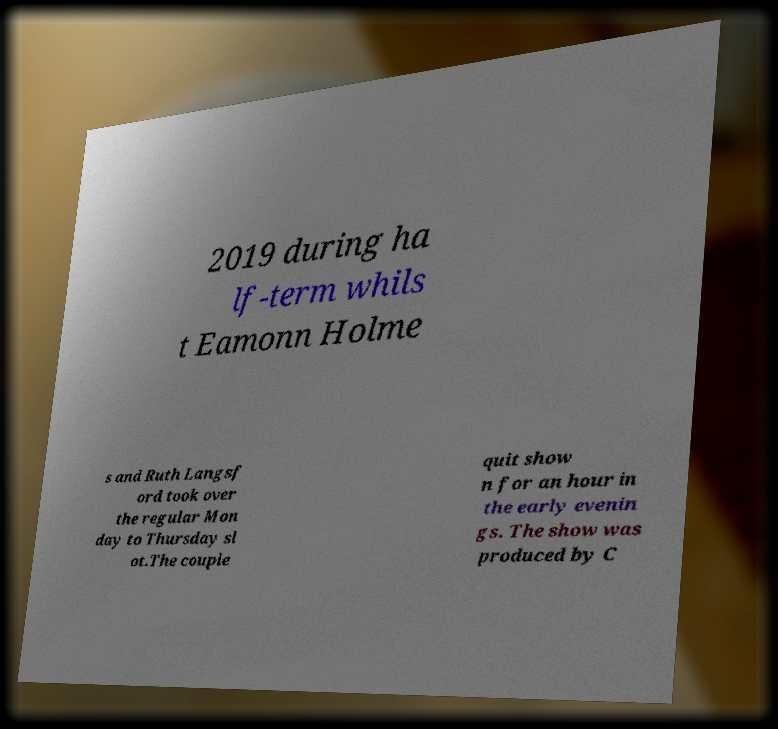Can you accurately transcribe the text from the provided image for me? 2019 during ha lf-term whils t Eamonn Holme s and Ruth Langsf ord took over the regular Mon day to Thursday sl ot.The couple quit show n for an hour in the early evenin gs. The show was produced by C 